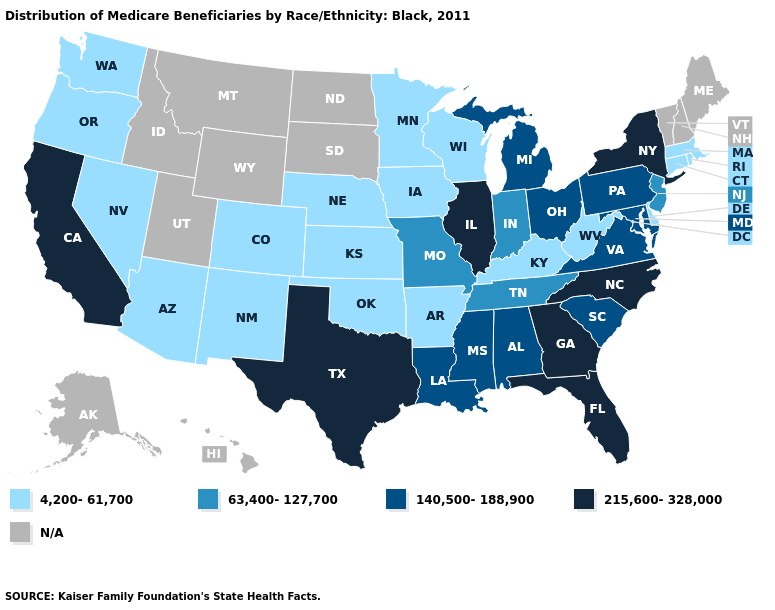Does Georgia have the highest value in the USA?
Keep it brief. Yes. How many symbols are there in the legend?
Concise answer only. 5. What is the highest value in states that border Idaho?
Quick response, please. 4,200-61,700. Which states have the lowest value in the South?
Give a very brief answer. Arkansas, Delaware, Kentucky, Oklahoma, West Virginia. How many symbols are there in the legend?
Short answer required. 5. Among the states that border Louisiana , does Arkansas have the lowest value?
Quick response, please. Yes. Does the map have missing data?
Write a very short answer. Yes. Among the states that border Maryland , which have the highest value?
Short answer required. Pennsylvania, Virginia. Name the states that have a value in the range 215,600-328,000?
Give a very brief answer. California, Florida, Georgia, Illinois, New York, North Carolina, Texas. What is the value of Pennsylvania?
Keep it brief. 140,500-188,900. Is the legend a continuous bar?
Answer briefly. No. What is the value of Alaska?
Quick response, please. N/A. 